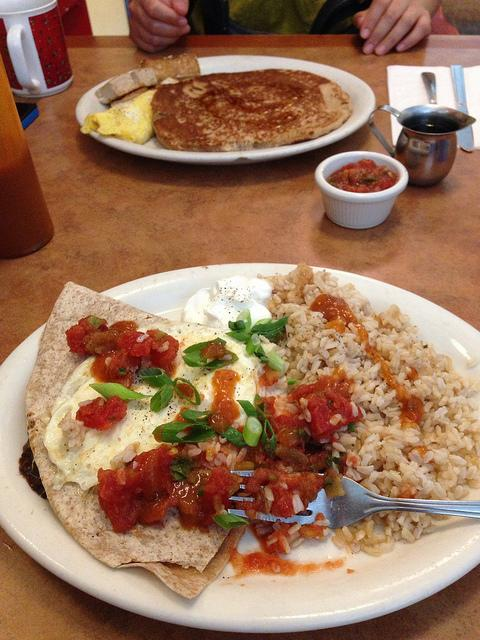What is the side dish on the plate in the foreground?

Choices:
A) oranges
B) apple slices
C) rice
D) fries rice 